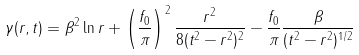Convert formula to latex. <formula><loc_0><loc_0><loc_500><loc_500>\gamma ( r , t ) = \beta ^ { 2 } \ln { r } + \left ( \frac { f _ { 0 } } { \pi } \right ) ^ { 2 } \frac { r ^ { 2 } } { 8 ( t ^ { 2 } - r ^ { 2 } ) ^ { 2 } } - \frac { f _ { 0 } } { \pi } \frac { \beta } { ( t ^ { 2 } - r ^ { 2 } ) ^ { 1 / 2 } }</formula> 